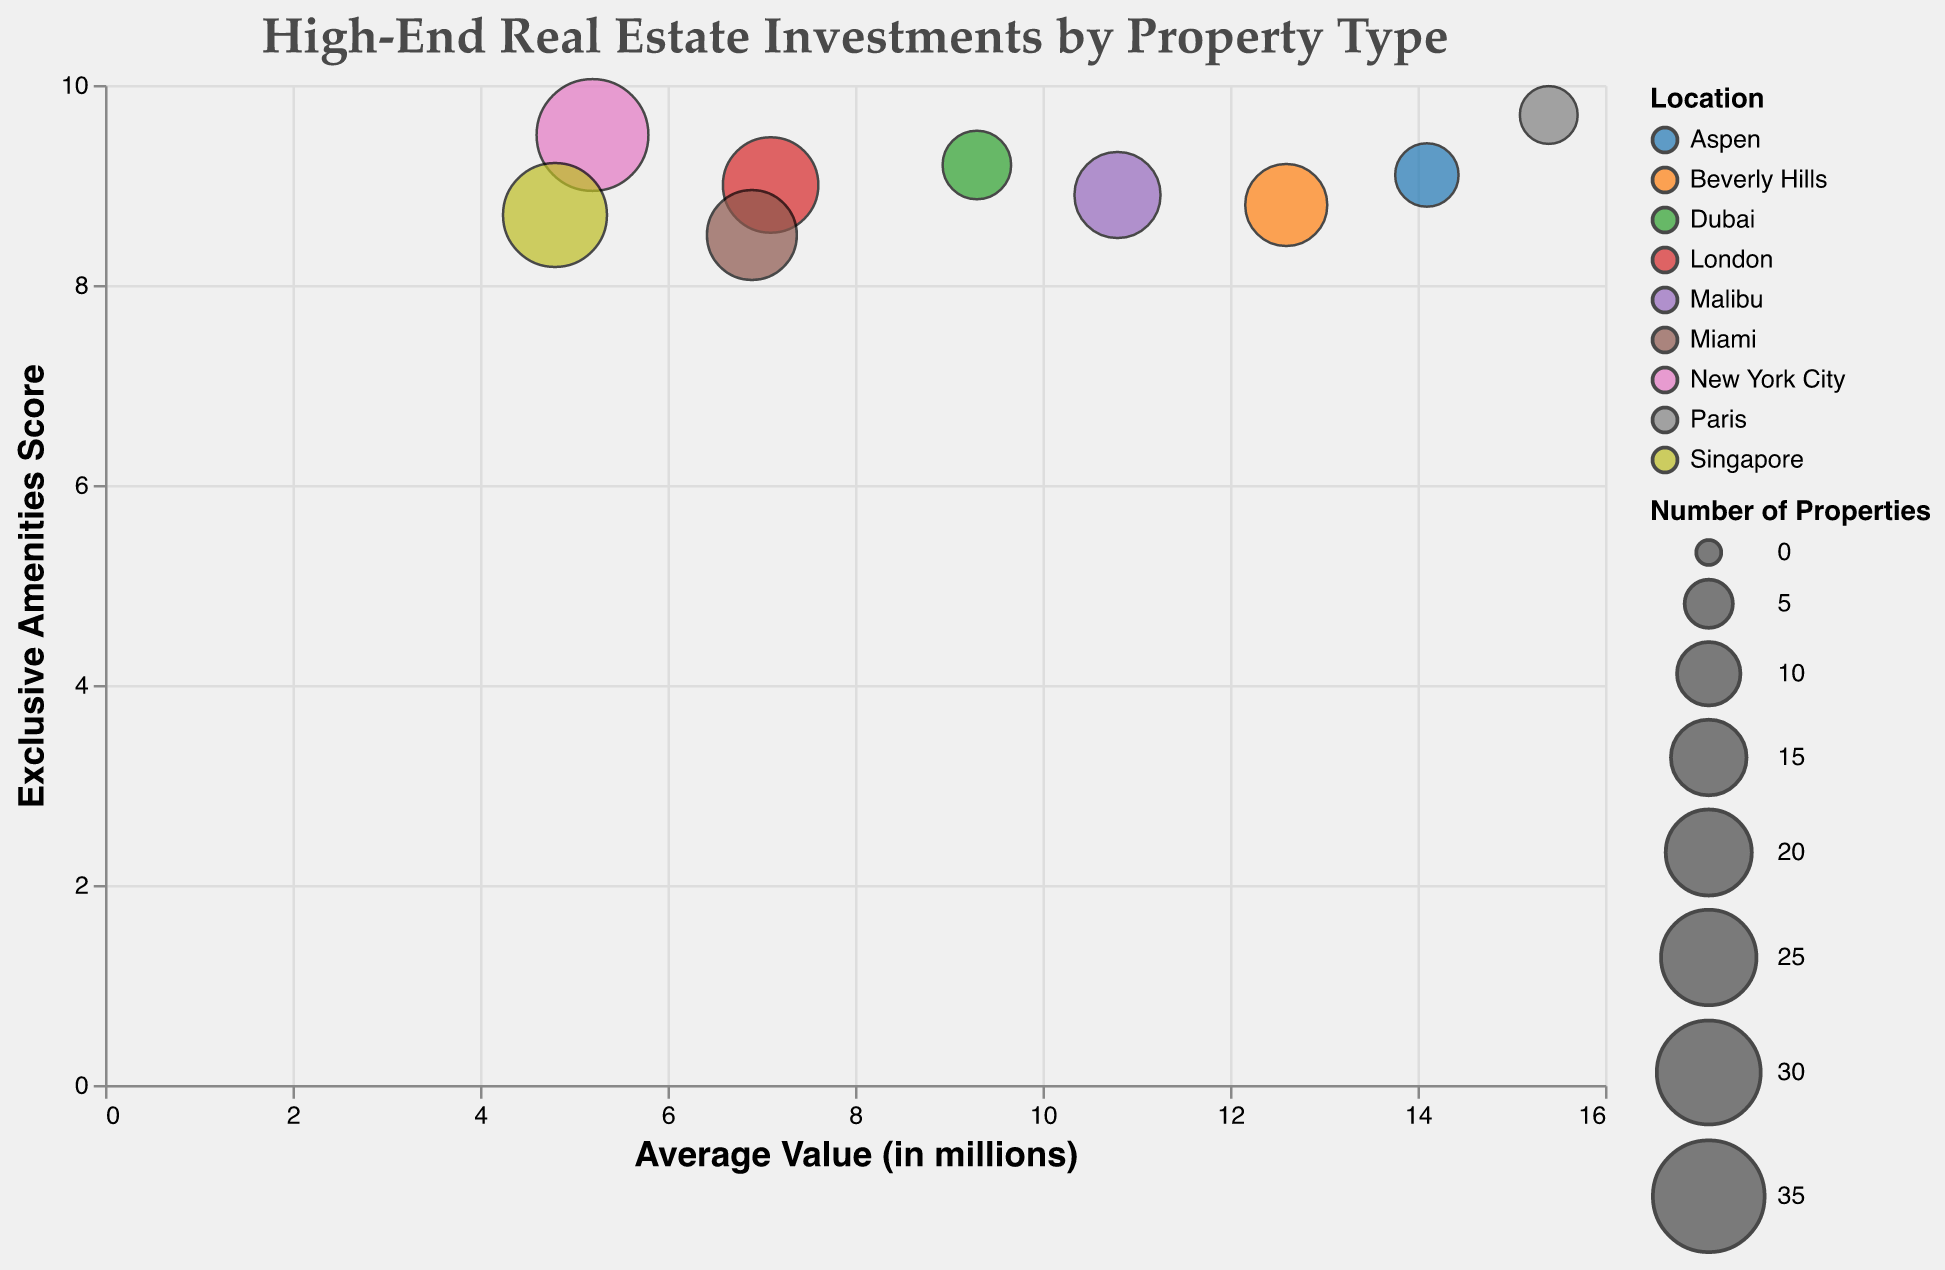Which property type has the highest average value? By examining the x-axis, which represents the average value in millions, we pinpoint the bubble farthest to the right. This bubble corresponds to Historical Chateaux with an average value of 15.4 million.
Answer: Historical Chateaux Which location has the most number of properties? The size of each bubble indicates the number of properties. The largest bubble corresponds to Luxury Apartments in New York City, indicating 35 properties.
Answer: New York City How does the average value of Urban Penthouses in London compare to Luxury Apartments in New York City? Urban Penthouses in London have an average value of 7.1 million, while Luxury Apartments in New York City have an average value of 5.2 million, making Urban Penthouses more valuable on average.
Answer: Urban Penthouses in London have a higher average value What is the exclusive amenities score for the property type with the least number of properties? The property type with the least number of properties is Historical Chateaux in Paris with 8 properties. The exclusive amenities score is 9.7.
Answer: 9.7 Which property type has both high exclusive amenities score and high average value? By looking for bubbles that are high on the y-axis and far on the x-axis, we identify Historical Chateaux in Paris, which has high scores in both dimensions (15.4 million average value and 9.7 exclusive amenities score).
Answer: Historical Chateaux What is the relationship between the number of properties and the average value for Modern Estates in Miami? Modern Estates in Miami have 22 properties, and an average value of 6.9 million. This indicates a moderate number of properties with a reasonably high average value.
Answer: Moderate number, reasonably high value Which property type and location combination has both high number of properties and high exclusive amenities score? The property type with the highest number of properties and high exclusive amenities score is Luxury Apartments in New York City with 35 properties and an amenities score of 9.5.
Answer: Luxury Apartments in New York City Is there a property type with fewer properties but a high average value? Historical Chateaux in Paris have only 8 properties but a high average value of 15.4 million.
Answer: Historical Chateaux How does the exclusive amenities score of Mountain Lodges in Aspen compare to Penthouse Suites in Dubai? Mountain Lodges in Aspen have an exclusive amenities score of 9.1, while Penthouse Suites in Dubai have a score of 9.2. The score for Penthouse Suites is slightly higher.
Answer: Penthouse Suites in Dubai have a slightly higher score Which property type has the highest exclusive amenities score, and what is it? By examining the y-axis representing the exclusive amenities score, we notice that Historical Chateaux in Paris has the highest score at 9.7.
Answer: Historical Chateaux, 9.7 